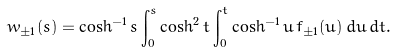Convert formula to latex. <formula><loc_0><loc_0><loc_500><loc_500>w _ { \pm 1 } ( s ) = \cosh ^ { - 1 } s \int _ { 0 } ^ { s } \cosh ^ { 2 } t \int _ { 0 } ^ { t } \cosh ^ { - 1 } u \, f _ { \pm 1 } ( u ) \, d u \, d t .</formula> 